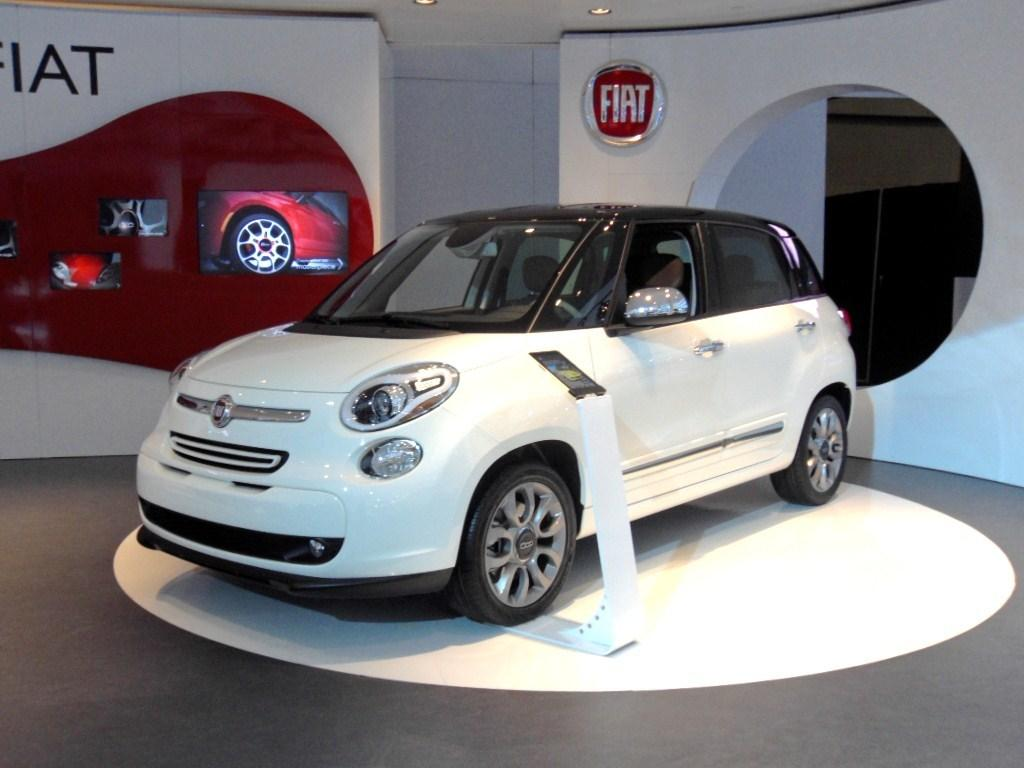What is placed on the floor in the image? There is a car on the floor. What objects in the image display visual information? There are screens in the image. What surface can be used for writing or displaying information? There is a board in the image. What illuminates the scene in the image? There are lights in the image. What type of structure is present in the background? There is a wall in the image. What type of cheese is being served by the secretary in the image? There is no cheese or secretary present in the image. 